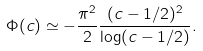Convert formula to latex. <formula><loc_0><loc_0><loc_500><loc_500>\Phi ( c ) \simeq - \frac { \pi ^ { 2 } } { 2 } \frac { ( c - 1 / 2 ) ^ { 2 } } { \log ( c - 1 / 2 ) } .</formula> 